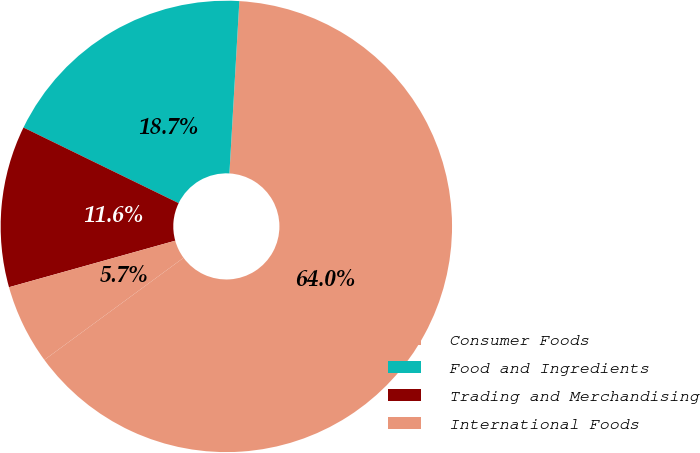Convert chart. <chart><loc_0><loc_0><loc_500><loc_500><pie_chart><fcel>Consumer Foods<fcel>Food and Ingredients<fcel>Trading and Merchandising<fcel>International Foods<nl><fcel>64.01%<fcel>18.7%<fcel>11.56%<fcel>5.73%<nl></chart> 